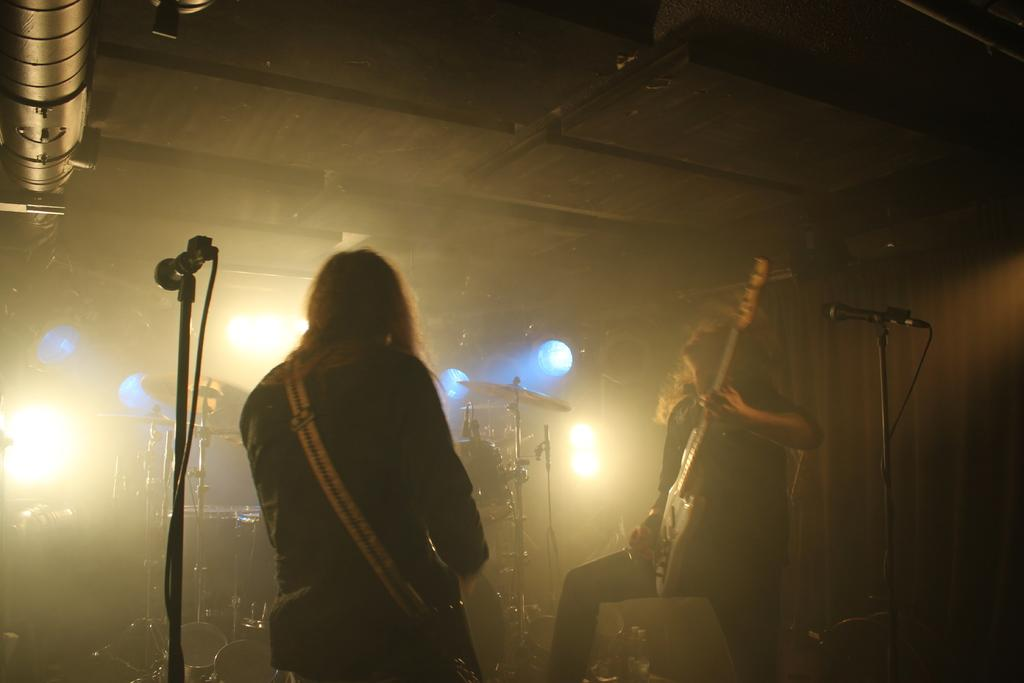How many people are in the image? There are two men in the image. What are the men doing in the image? The men are standing and playing guitar. What objects can be seen in the image related to music? There are microphones and drums in the image. What can be seen in the background of the image? There are lights in the background of the image. What type of magic trick is the man performing with the coil in the image? There is no magic trick or coil present in the image. What discovery was made by the men in the image? There is no mention of a discovery in the image. 